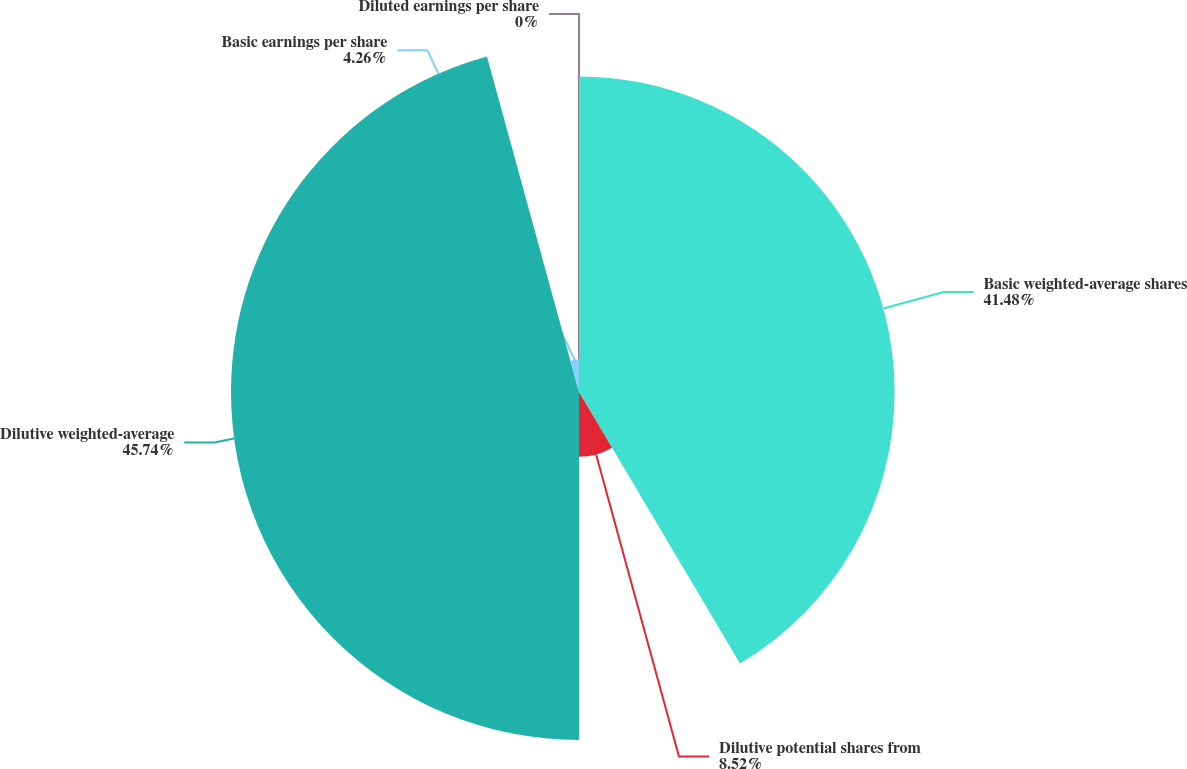Convert chart to OTSL. <chart><loc_0><loc_0><loc_500><loc_500><pie_chart><fcel>Basic weighted-average shares<fcel>Dilutive potential shares from<fcel>Dilutive weighted-average<fcel>Basic earnings per share<fcel>Diluted earnings per share<nl><fcel>41.48%<fcel>8.52%<fcel>45.74%<fcel>4.26%<fcel>0.0%<nl></chart> 